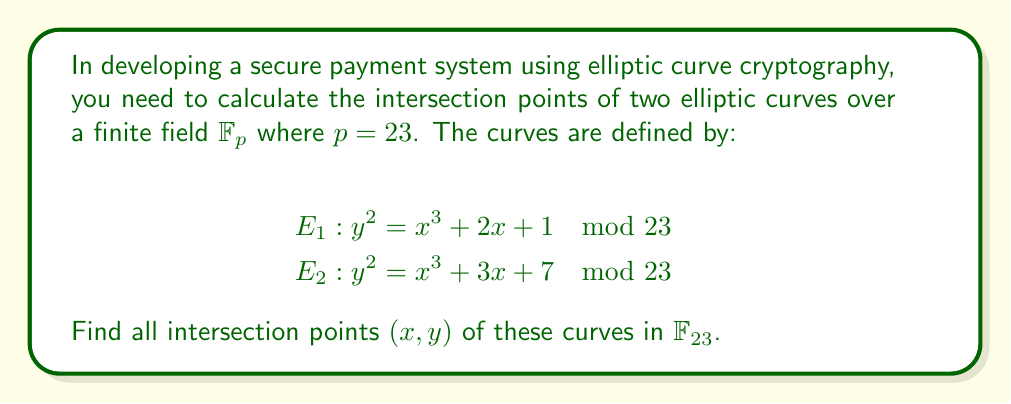Help me with this question. To find the intersection points, we need to solve the system of equations:

$$y^2 = x^3 + 2x + 1 \mod 23$$
$$y^2 = x^3 + 3x + 7 \mod 23$$

Step 1: Equate the right-hand sides of both equations:
$$x^3 + 2x + 1 \equiv x^3 + 3x + 7 \pmod{23}$$

Step 2: Simplify the equation:
$$2x + 1 \equiv 3x + 7 \pmod{23}$$
$$-x \equiv 6 \pmod{23}$$
$$x \equiv -6 \equiv 17 \pmod{23}$$

Step 3: Substitute $x = 17$ into either of the original equations. We'll use $E_1$:
$$y^2 \equiv 17^3 + 2(17) + 1 \pmod{23}$$
$$y^2 \equiv 4913 + 34 + 1 \pmod{23}$$
$$y^2 \equiv 4948 \equiv 9 \pmod{23}$$

Step 4: Solve for $y$:
$$y \equiv \pm 3 \pmod{23}$$

Therefore, the intersection points are $(17, 3)$ and $(17, 20)$ in $\mathbb{F}_{23}$.
Answer: $(17, 3)$ and $(17, 20)$ 